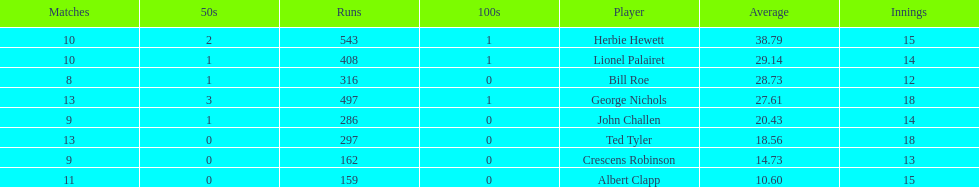What is the number of players who participated in over 10 matches? 3. 